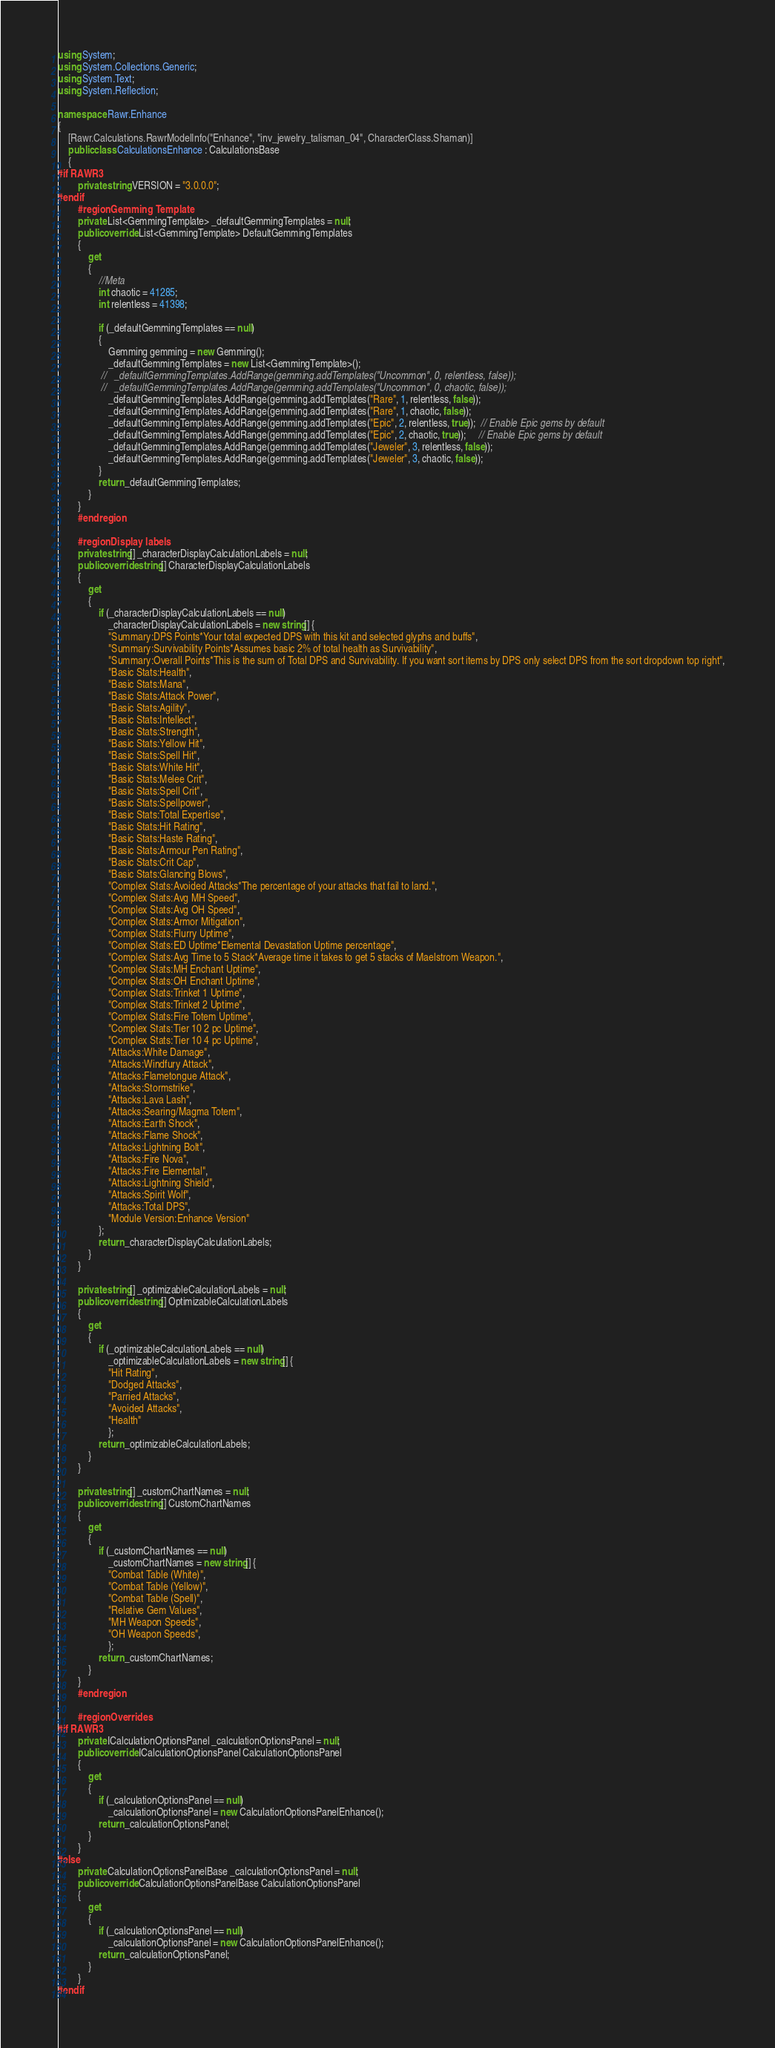<code> <loc_0><loc_0><loc_500><loc_500><_C#_>using System;
using System.Collections.Generic;
using System.Text;
using System.Reflection;

namespace Rawr.Enhance
{
    [Rawr.Calculations.RawrModelInfo("Enhance", "inv_jewelry_talisman_04", CharacterClass.Shaman)]
	public class CalculationsEnhance : CalculationsBase
    {
#if RAWR3
        private string VERSION = "3.0.0.0";
#endif
        #region Gemming Template
        private List<GemmingTemplate> _defaultGemmingTemplates = null;
        public override List<GemmingTemplate> DefaultGemmingTemplates
        {
            get
            {
                //Meta
                int chaotic = 41285;
                int relentless = 41398;

                if (_defaultGemmingTemplates == null)
                {
                    Gemming gemming = new Gemming();
                    _defaultGemmingTemplates = new List<GemmingTemplate>();
                 //   _defaultGemmingTemplates.AddRange(gemming.addTemplates("Uncommon", 0, relentless, false));
                 //   _defaultGemmingTemplates.AddRange(gemming.addTemplates("Uncommon", 0, chaotic, false));
                    _defaultGemmingTemplates.AddRange(gemming.addTemplates("Rare", 1, relentless, false)); 
                    _defaultGemmingTemplates.AddRange(gemming.addTemplates("Rare", 1, chaotic, false));    
                    _defaultGemmingTemplates.AddRange(gemming.addTemplates("Epic", 2, relentless, true));  // Enable Epic gems by default
                    _defaultGemmingTemplates.AddRange(gemming.addTemplates("Epic", 2, chaotic, true));     // Enable Epic gems by default
                    _defaultGemmingTemplates.AddRange(gemming.addTemplates("Jeweler", 3, relentless, false));
                    _defaultGemmingTemplates.AddRange(gemming.addTemplates("Jeweler", 3, chaotic, false)); 
                }
                return _defaultGemmingTemplates;
            }
        }
        #endregion

        #region Display labels
        private string[] _characterDisplayCalculationLabels = null;
		public override string[] CharacterDisplayCalculationLabels
		{
			get
			{
				if (_characterDisplayCalculationLabels == null)
					_characterDisplayCalculationLabels = new string[] {
                    "Summary:DPS Points*Your total expected DPS with this kit and selected glyphs and buffs",
                    "Summary:Survivability Points*Assumes basic 2% of total health as Survivability",
                    "Summary:Overall Points*This is the sum of Total DPS and Survivability. If you want sort items by DPS only select DPS from the sort dropdown top right",
					"Basic Stats:Health",
                    "Basic Stats:Mana",
					"Basic Stats:Attack Power",
					"Basic Stats:Agility",
					"Basic Stats:Intellect",
                    "Basic Stats:Strength",
                    "Basic Stats:Yellow Hit",
                    "Basic Stats:Spell Hit",
					"Basic Stats:White Hit",
                    "Basic Stats:Melee Crit",
                    "Basic Stats:Spell Crit",
                    "Basic Stats:Spellpower",
					"Basic Stats:Total Expertise",
   				    "Basic Stats:Hit Rating",
					"Basic Stats:Haste Rating",
					"Basic Stats:Armour Pen Rating",
                    "Basic Stats:Crit Cap",
                    "Basic Stats:Glancing Blows",
					"Complex Stats:Avoided Attacks*The percentage of your attacks that fail to land.",
					"Complex Stats:Avg MH Speed",
                    "Complex Stats:Avg OH Speed",
					"Complex Stats:Armor Mitigation",
                    "Complex Stats:Flurry Uptime",
                    "Complex Stats:ED Uptime*Elemental Devastation Uptime percentage",
                    "Complex Stats:Avg Time to 5 Stack*Average time it takes to get 5 stacks of Maelstrom Weapon.",
                    "Complex Stats:MH Enchant Uptime",
                    "Complex Stats:OH Enchant Uptime",
                    "Complex Stats:Trinket 1 Uptime",
                    "Complex Stats:Trinket 2 Uptime",
                    "Complex Stats:Fire Totem Uptime",
                    "Complex Stats:Tier 10 2 pc Uptime",
                    "Complex Stats:Tier 10 4 pc Uptime",
                    "Attacks:White Damage",
                    "Attacks:Windfury Attack",
                    "Attacks:Flametongue Attack",
                    "Attacks:Stormstrike",
                    "Attacks:Lava Lash",
                    "Attacks:Searing/Magma Totem",
                    "Attacks:Earth Shock",
                    "Attacks:Flame Shock",
                    "Attacks:Lightning Bolt",
                    "Attacks:Fire Nova",
                    "Attacks:Fire Elemental",
                    "Attacks:Lightning Shield",
                    "Attacks:Spirit Wolf",
                    "Attacks:Total DPS",
                    "Module Version:Enhance Version"
				};
				return _characterDisplayCalculationLabels;
			}
		}

		private string[] _optimizableCalculationLabels = null;
		public override string[] OptimizableCalculationLabels
		{
			get
			{
				if (_optimizableCalculationLabels == null)
					_optimizableCalculationLabels = new string[] {
					"Hit Rating",
                    "Dodged Attacks",
                    "Parried Attacks",
                    "Avoided Attacks",
                    "Health"
					};
				return _optimizableCalculationLabels;
			}
		}

		private string[] _customChartNames = null;
		public override string[] CustomChartNames
		{
			get
			{
				if (_customChartNames == null)
					_customChartNames = new string[] {
					"Combat Table (White)",
					"Combat Table (Yellow)",
                    "Combat Table (Spell)",
					"Relative Gem Values",
                    "MH Weapon Speeds",
                    "OH Weapon Speeds",
					};
				return _customChartNames;
			}
        }
        #endregion 

        #region Overrides
#if RAWR3
        private ICalculationOptionsPanel _calculationOptionsPanel = null;
        public override ICalculationOptionsPanel CalculationOptionsPanel
        {
            get
            {
                if (_calculationOptionsPanel == null)
                    _calculationOptionsPanel = new CalculationOptionsPanelEnhance();
                return _calculationOptionsPanel;
            }
        }
#else
        private CalculationOptionsPanelBase _calculationOptionsPanel = null;
        public override CalculationOptionsPanelBase CalculationOptionsPanel
        {
            get
            {
                if (_calculationOptionsPanel == null)
                    _calculationOptionsPanel = new CalculationOptionsPanelEnhance();
                return _calculationOptionsPanel;
            }
        }
#endif
</code> 